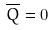Convert formula to latex. <formula><loc_0><loc_0><loc_500><loc_500>\overline { Q } = 0</formula> 